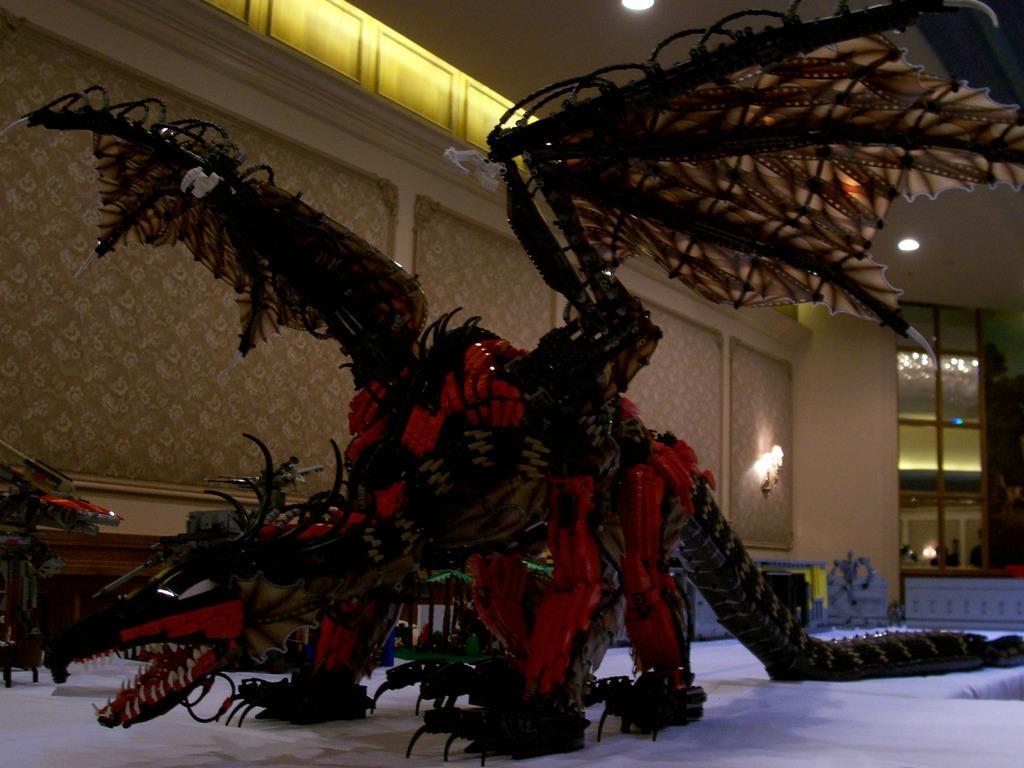Describe this image in one or two sentences. In this image we can see there is a depiction of a dinosaur. In the background there is a wall and few lamps are hanging on it. At the top of the image there is a ceiling. 